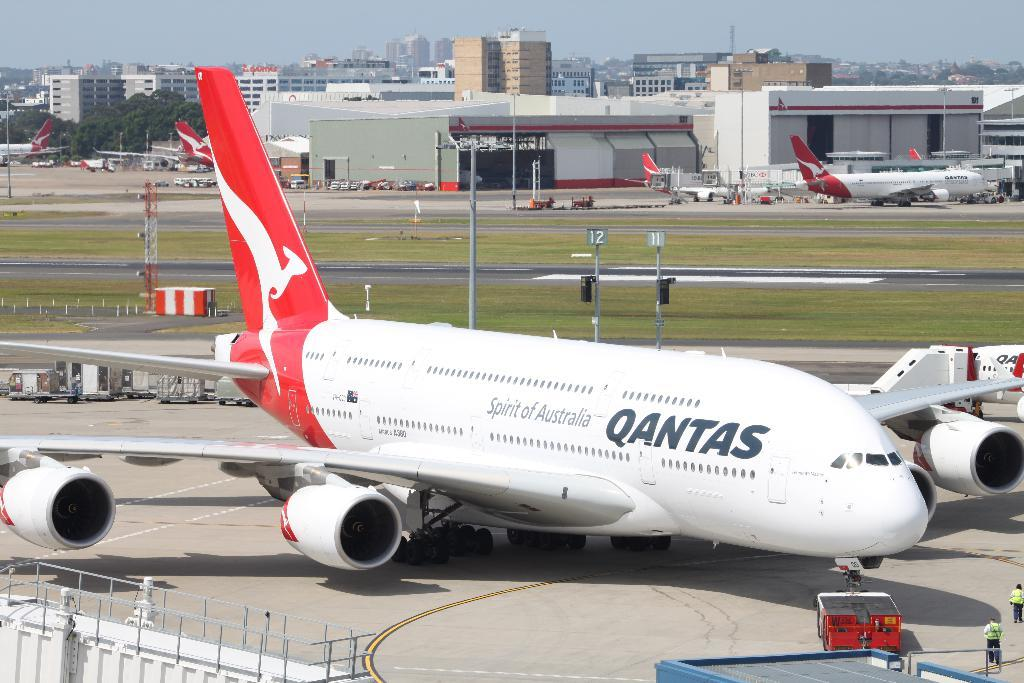<image>
Describe the image concisely. a Qantas airlines plane sits on the tarmac waiting to be serviced 